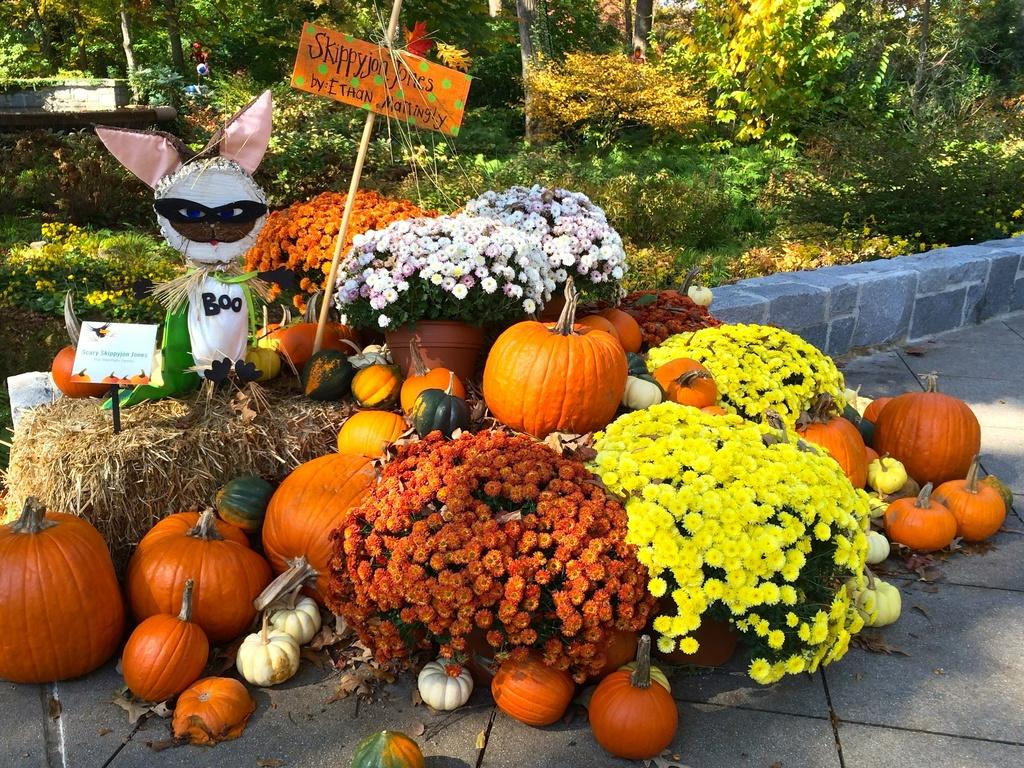What objects are present on both sides of the image? There are pumpkins on both the left and right sides of the image. What type of vegetation can be seen in the image? There are flowers visible in the image. What can be seen in the background of the image? There are trees in the background of the image. Where is the queen sitting in the carriage in the image? There is no carriage or queen present in the image; it features pumpkins and flowers. What type of stitch is used to create the flowers in the image? The flowers in the image are not handmade or stitched; they are real flowers. 